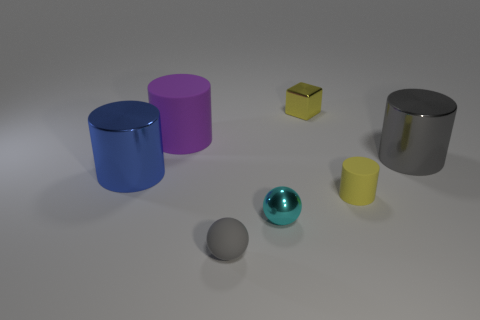What can you infer about the positioning of objects in relation to each other? The objects are arranged with varying distances from each other. The pink and the blue cylinders are side by side, while the yellow cube is isolated further to the right. The tiny cyan shiny sphere and the small matte gray sphere are in the foreground, suggesting that they are closer to the viewer, whereas the yellow matte cube and the larger gray cube appear to be in the background, possibly on an elevated plane, given the perspective. 